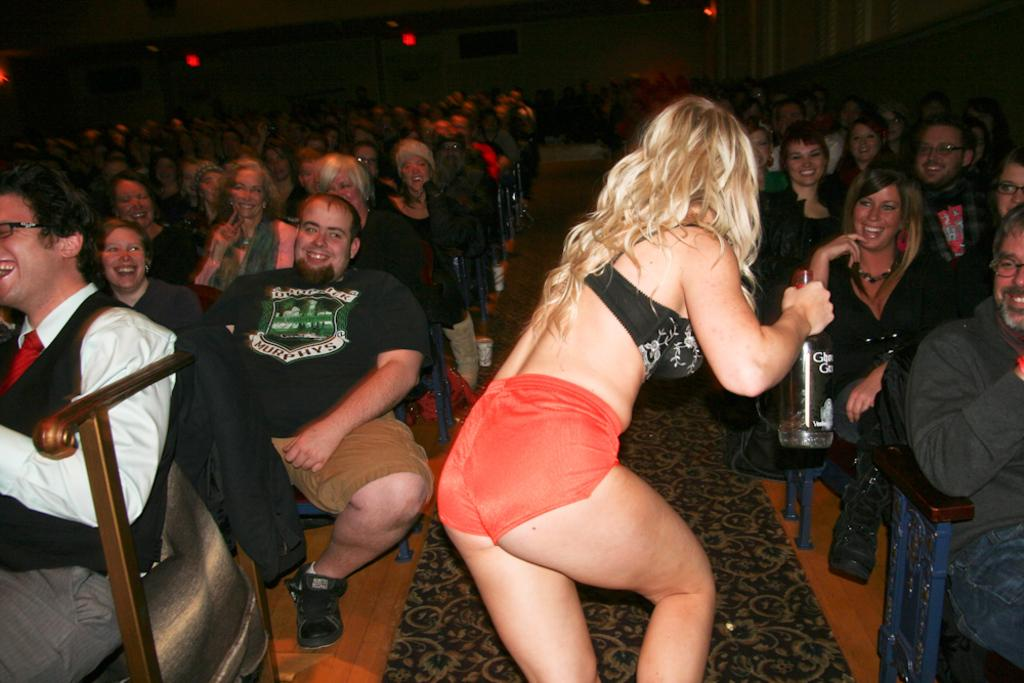Who is the main subject in the foreground of the image? There is a woman in the foreground of the image. What is the woman holding in her hand? The woman is holding a bottle in her hand. What are the people around the woman doing? There are many people sitting around the woman, and they are watching her. What type of church can be seen in the background of the image? There is no church visible in the image; it only shows a woman holding a bottle and people watching her. 